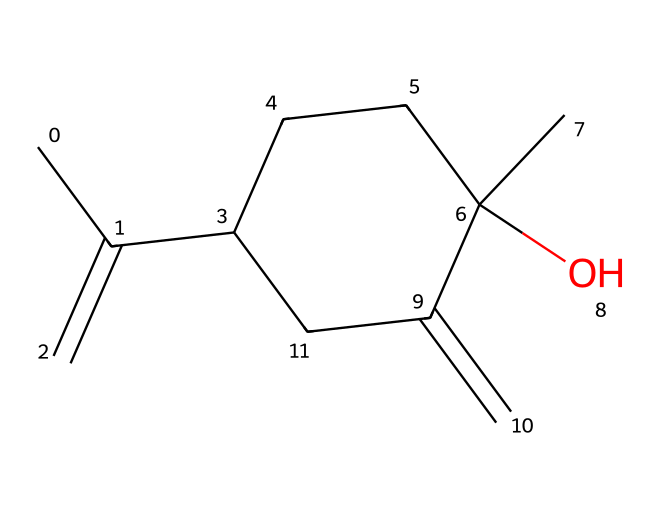What is the molecular formula of lavender essential oil based on the SMILES provided? By interpreting the SMILES representation, we can determine the molecular composition by counting the carbon (C), hydrogen (H), and oxygen (O) atoms. There are 15 carbon atoms, 24 hydrogen atoms, and 1 oxygen atom. Thus, the molecular formula is C15H24O.
Answer: C15H24O How many rings are present in the structure of lavender essential oil? Analyzing the structure by looking for closed loops, we can identify one cycloalkane ring indicated by the pattern of the carbons connected in the SMILES. This shows there is one ring in the molecular structure.
Answer: one What type of functional group is present in this chemical? In the provided SMILES, the presence of an -OH (hydroxyl) group, indicated by the "O" surrounded by the carbon chain, shows that this is an alcohol functional group.
Answer: alcohol What is the most prominent element in lavender essential oil? By looking at the molecular formula derived earlier (C15H24O), we can see that carbon (C) has the highest atomic count, indicating that it is the most prominent element in the structure.
Answer: carbon Does this chemical exhibit polarity? The presence of the hydroxyl (-OH) group suggests that the molecule has polar characteristics due to the electronegativity difference between oxygen and hydrogen, making the overall structure partially polar.
Answer: yes What is the significance of the cyclohexane ring in this structure? The cyclohexane ring contributes to the stable structure and overall properties of lavender essential oil. It plays a crucial role in the hydrophobic character of the molecule, affecting its aroma and interactions.
Answer: stability and hydrophobicity 